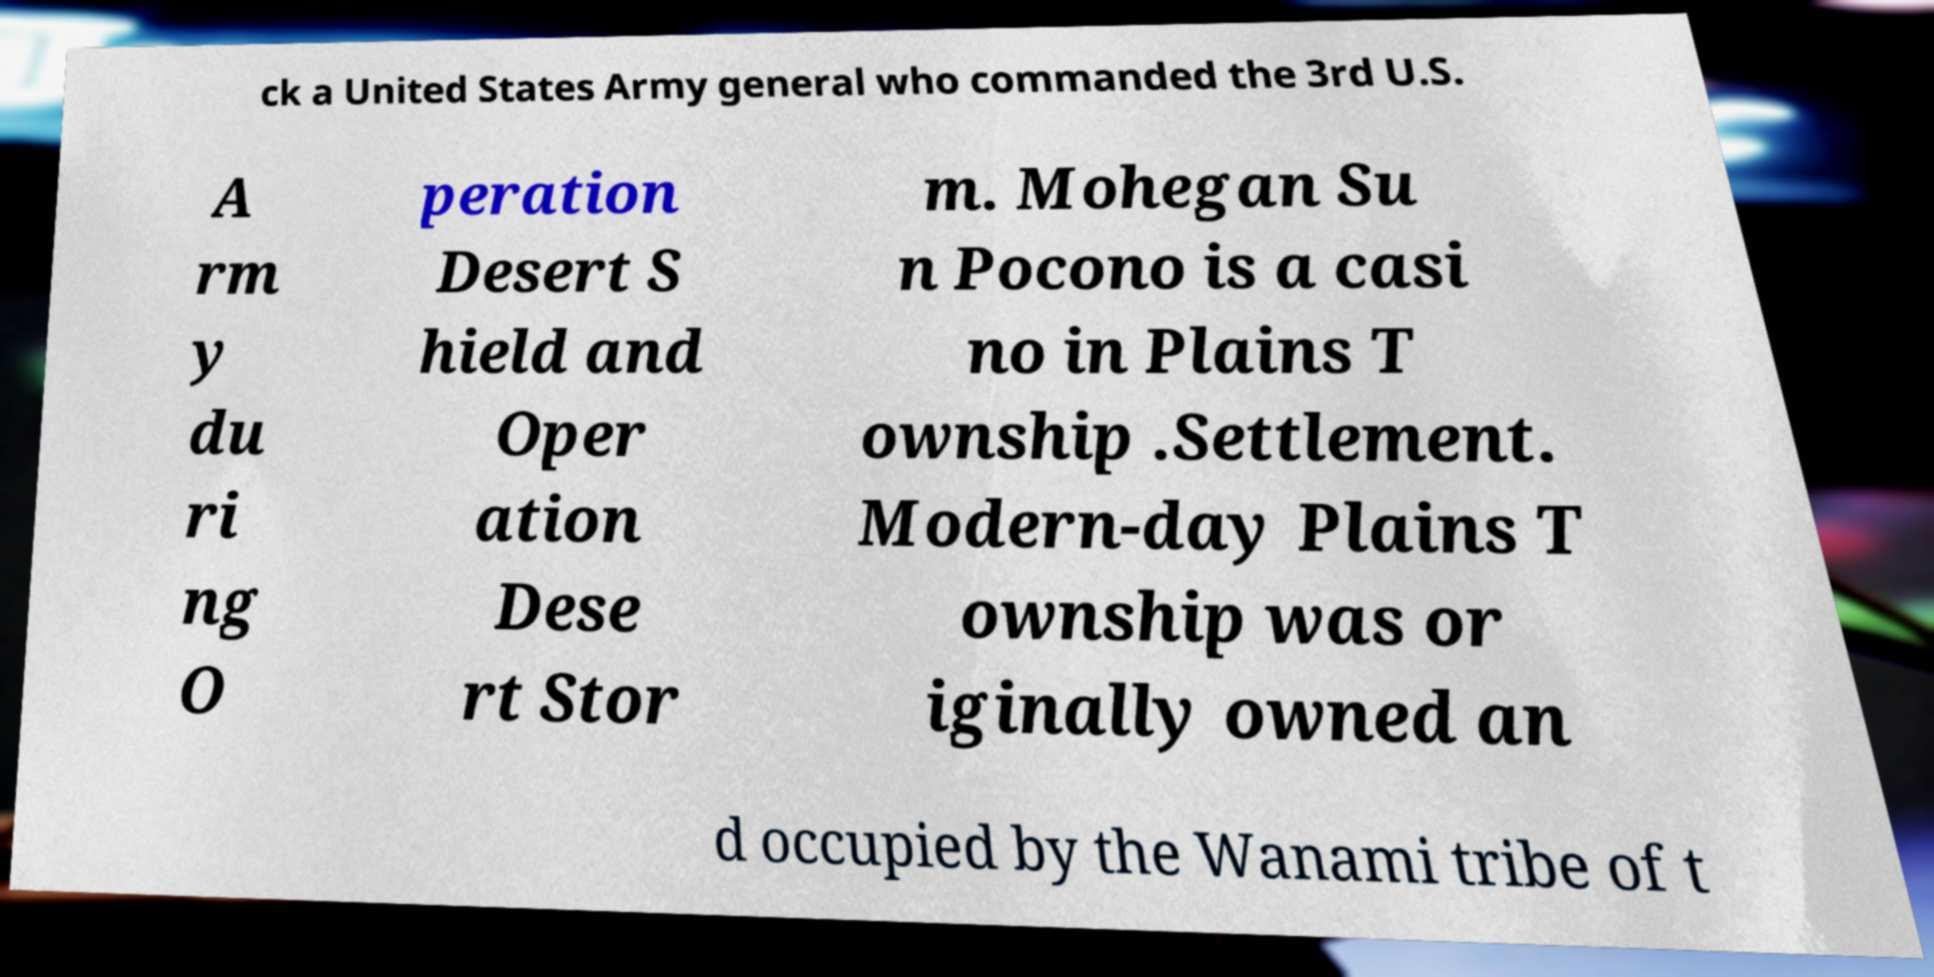Can you accurately transcribe the text from the provided image for me? ck a United States Army general who commanded the 3rd U.S. A rm y du ri ng O peration Desert S hield and Oper ation Dese rt Stor m. Mohegan Su n Pocono is a casi no in Plains T ownship .Settlement. Modern-day Plains T ownship was or iginally owned an d occupied by the Wanami tribe of t 